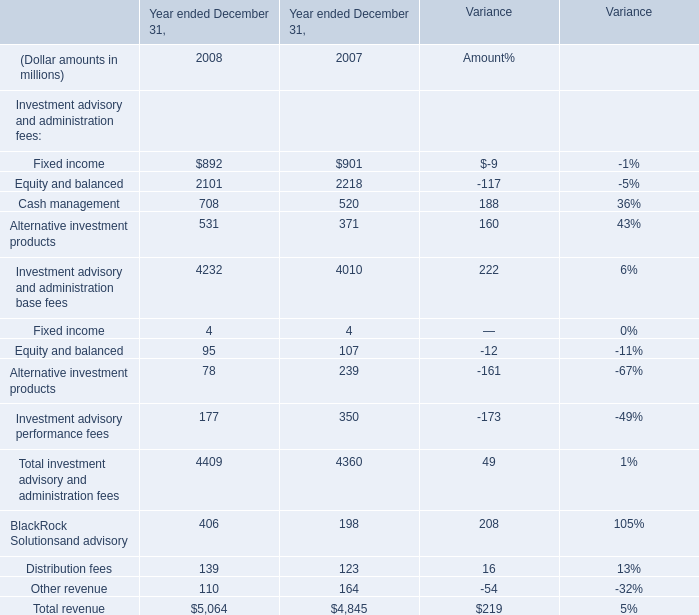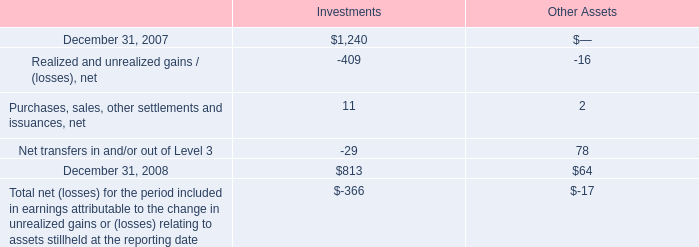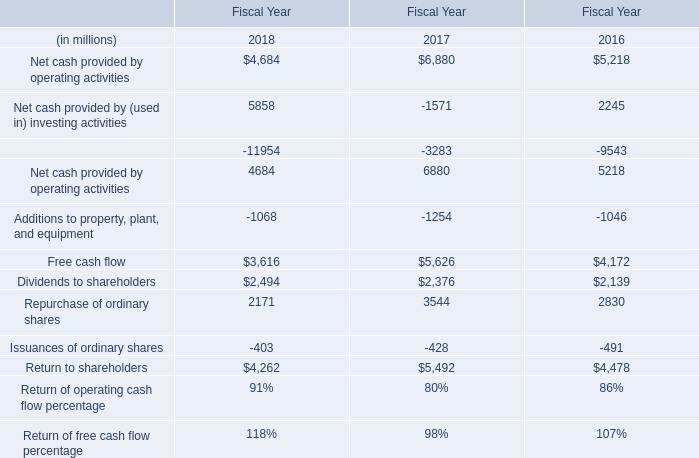What's the average of December 31, 2007 of Investments, and Additions to property, plant, and equipment of Fiscal Year 2018 ? 
Computations: ((1240.0 + 1068.0) / 2)
Answer: 1154.0. 